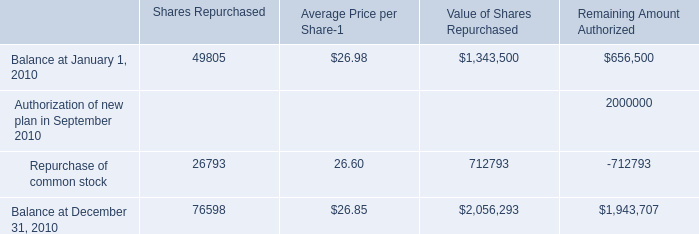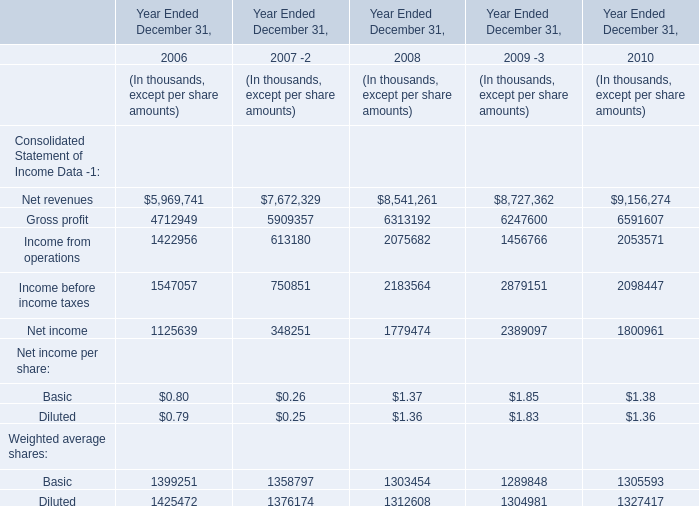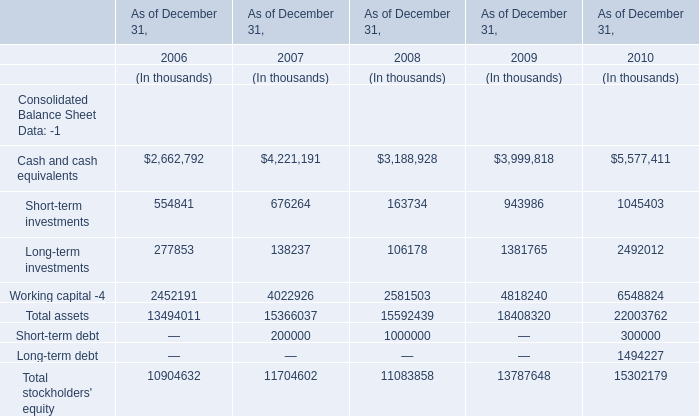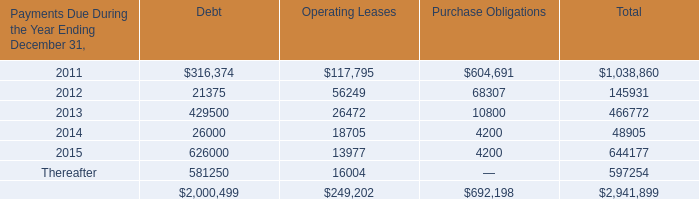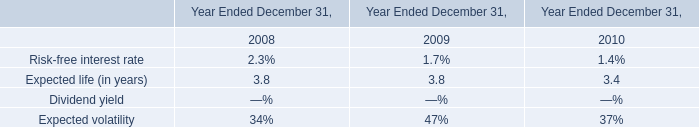Which Consolidated Balance Sheet Data has the second largest number in 2006? 
Answer: Total stockholders' equity. 